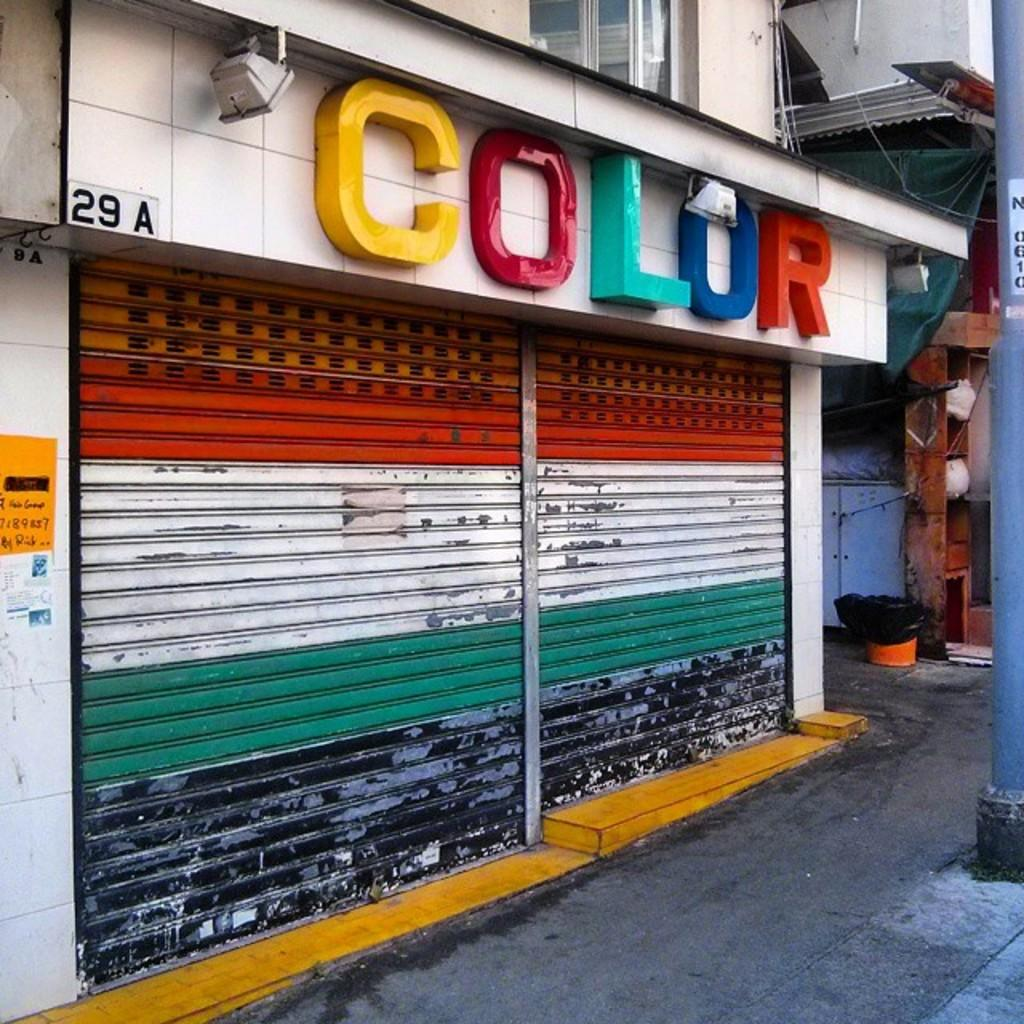What type of structures can be seen in the image? There are buildings in the image. Can you describe any specific feature of the buildings? There is there a rolling shutter in the image? What type of powder is being used to prepare the stew in the image? There is no stew or powder present in the image; it features buildings and a rolling shutter. 